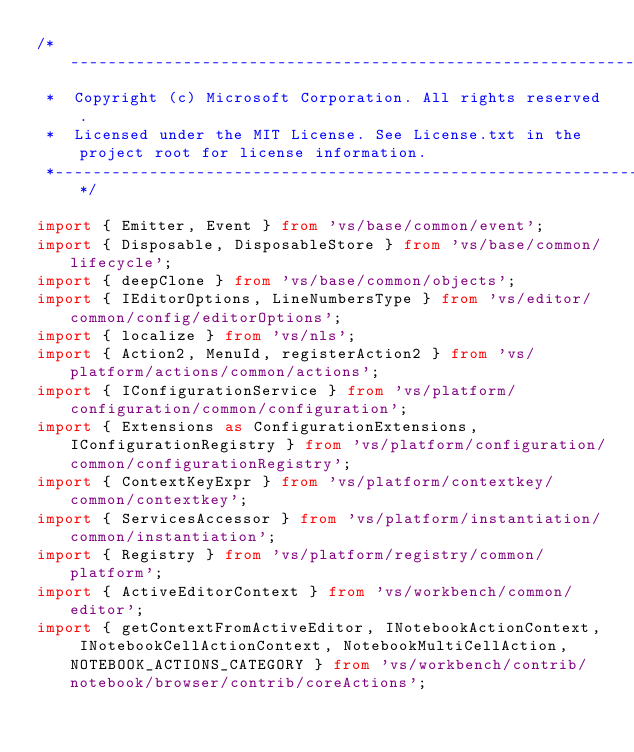Convert code to text. <code><loc_0><loc_0><loc_500><loc_500><_TypeScript_>/*---------------------------------------------------------------------------------------------
 *  Copyright (c) Microsoft Corporation. All rights reserved.
 *  Licensed under the MIT License. See License.txt in the project root for license information.
 *--------------------------------------------------------------------------------------------*/

import { Emitter, Event } from 'vs/base/common/event';
import { Disposable, DisposableStore } from 'vs/base/common/lifecycle';
import { deepClone } from 'vs/base/common/objects';
import { IEditorOptions, LineNumbersType } from 'vs/editor/common/config/editorOptions';
import { localize } from 'vs/nls';
import { Action2, MenuId, registerAction2 } from 'vs/platform/actions/common/actions';
import { IConfigurationService } from 'vs/platform/configuration/common/configuration';
import { Extensions as ConfigurationExtensions, IConfigurationRegistry } from 'vs/platform/configuration/common/configurationRegistry';
import { ContextKeyExpr } from 'vs/platform/contextkey/common/contextkey';
import { ServicesAccessor } from 'vs/platform/instantiation/common/instantiation';
import { Registry } from 'vs/platform/registry/common/platform';
import { ActiveEditorContext } from 'vs/workbench/common/editor';
import { getContextFromActiveEditor, INotebookActionContext, INotebookCellActionContext, NotebookMultiCellAction, NOTEBOOK_ACTIONS_CATEGORY } from 'vs/workbench/contrib/notebook/browser/contrib/coreActions';</code> 